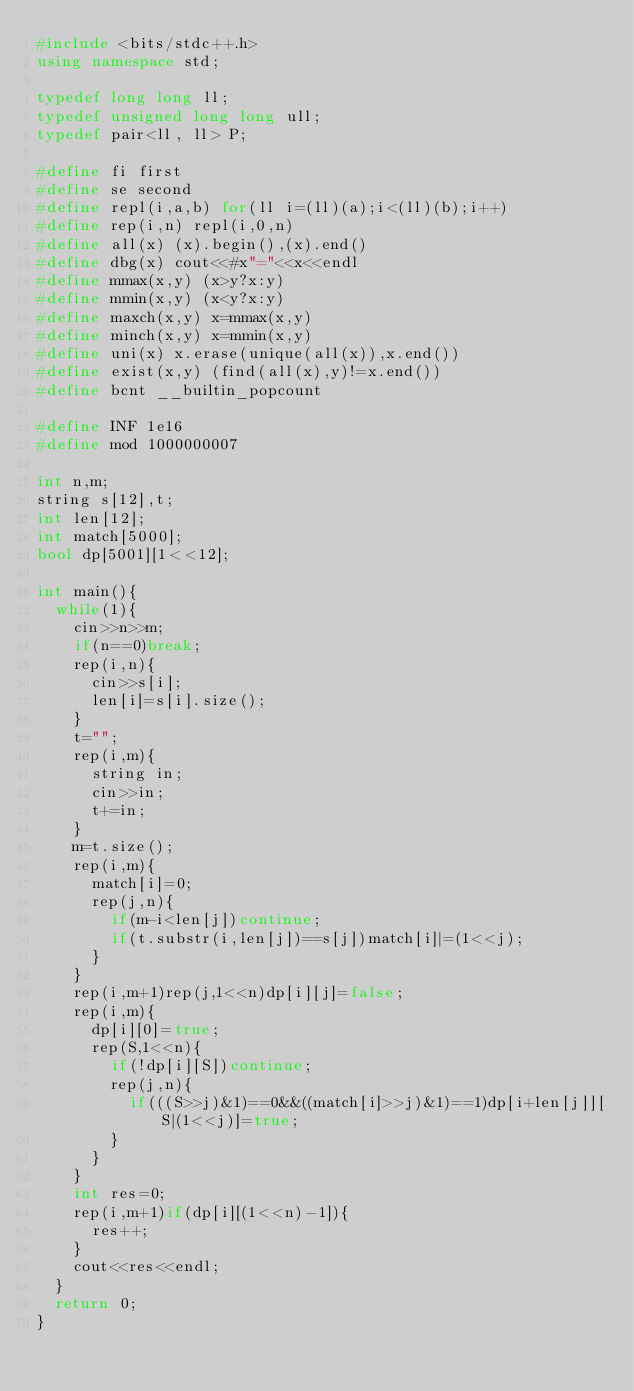Convert code to text. <code><loc_0><loc_0><loc_500><loc_500><_C++_>#include <bits/stdc++.h>
using namespace std;

typedef long long ll;
typedef unsigned long long ull;
typedef pair<ll, ll> P;

#define fi first
#define se second
#define repl(i,a,b) for(ll i=(ll)(a);i<(ll)(b);i++)
#define rep(i,n) repl(i,0,n)
#define all(x) (x).begin(),(x).end()
#define dbg(x) cout<<#x"="<<x<<endl
#define mmax(x,y) (x>y?x:y)
#define mmin(x,y) (x<y?x:y)
#define maxch(x,y) x=mmax(x,y)
#define minch(x,y) x=mmin(x,y)
#define uni(x) x.erase(unique(all(x)),x.end())
#define exist(x,y) (find(all(x),y)!=x.end())
#define bcnt __builtin_popcount

#define INF 1e16
#define mod 1000000007

int n,m;
string s[12],t;
int len[12];
int match[5000];
bool dp[5001][1<<12];

int main(){
  while(1){
    cin>>n>>m;
    if(n==0)break;
    rep(i,n){
      cin>>s[i];
      len[i]=s[i].size();
    }
    t="";
    rep(i,m){
      string in;
      cin>>in;
      t+=in;
    }
    m=t.size();
    rep(i,m){
      match[i]=0;
      rep(j,n){
        if(m-i<len[j])continue;
        if(t.substr(i,len[j])==s[j])match[i]|=(1<<j);
      }
    }
    rep(i,m+1)rep(j,1<<n)dp[i][j]=false;
    rep(i,m){
      dp[i][0]=true;
      rep(S,1<<n){
        if(!dp[i][S])continue;
        rep(j,n){
          if(((S>>j)&1)==0&&((match[i]>>j)&1)==1)dp[i+len[j]][S|(1<<j)]=true;
        }
      }
    }
    int res=0;
    rep(i,m+1)if(dp[i][(1<<n)-1]){
      res++;
    }
    cout<<res<<endl;
  }
  return 0;
}

</code> 